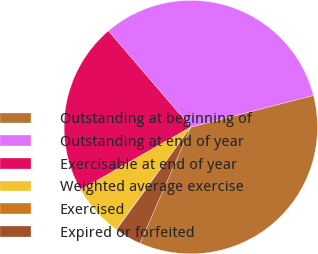Convert chart. <chart><loc_0><loc_0><loc_500><loc_500><pie_chart><fcel>Outstanding at beginning of<fcel>Outstanding at end of year<fcel>Exercisable at end of year<fcel>Weighted average exercise<fcel>Exercised<fcel>Expired or forfeited<nl><fcel>35.58%<fcel>32.25%<fcel>21.96%<fcel>6.73%<fcel>0.07%<fcel>3.4%<nl></chart> 